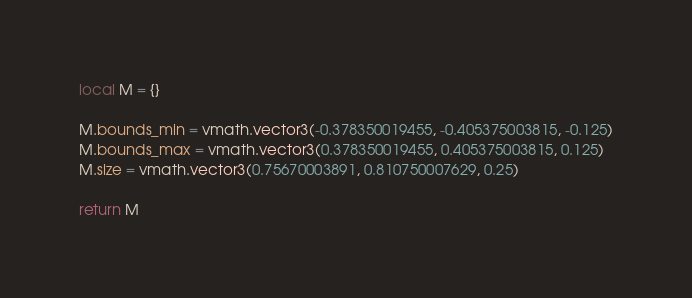Convert code to text. <code><loc_0><loc_0><loc_500><loc_500><_Lua_>local M = {}

M.bounds_min = vmath.vector3(-0.378350019455, -0.405375003815, -0.125)
M.bounds_max = vmath.vector3(0.378350019455, 0.405375003815, 0.125)
M.size = vmath.vector3(0.75670003891, 0.810750007629, 0.25)

return M
</code> 